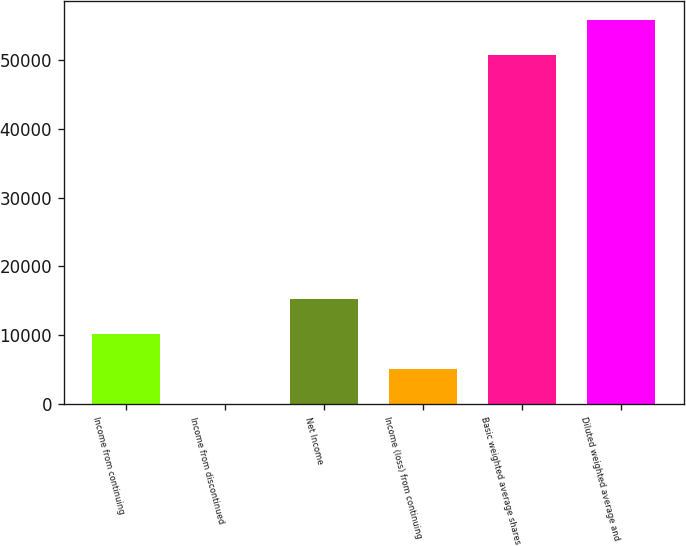Convert chart to OTSL. <chart><loc_0><loc_0><loc_500><loc_500><bar_chart><fcel>Income from continuing<fcel>Income from discontinued<fcel>Net Income<fcel>Income (loss) from continuing<fcel>Basic weighted average shares<fcel>Diluted weighted average and<nl><fcel>10213.6<fcel>1.3<fcel>15319.8<fcel>5107.47<fcel>50693<fcel>55799.2<nl></chart> 